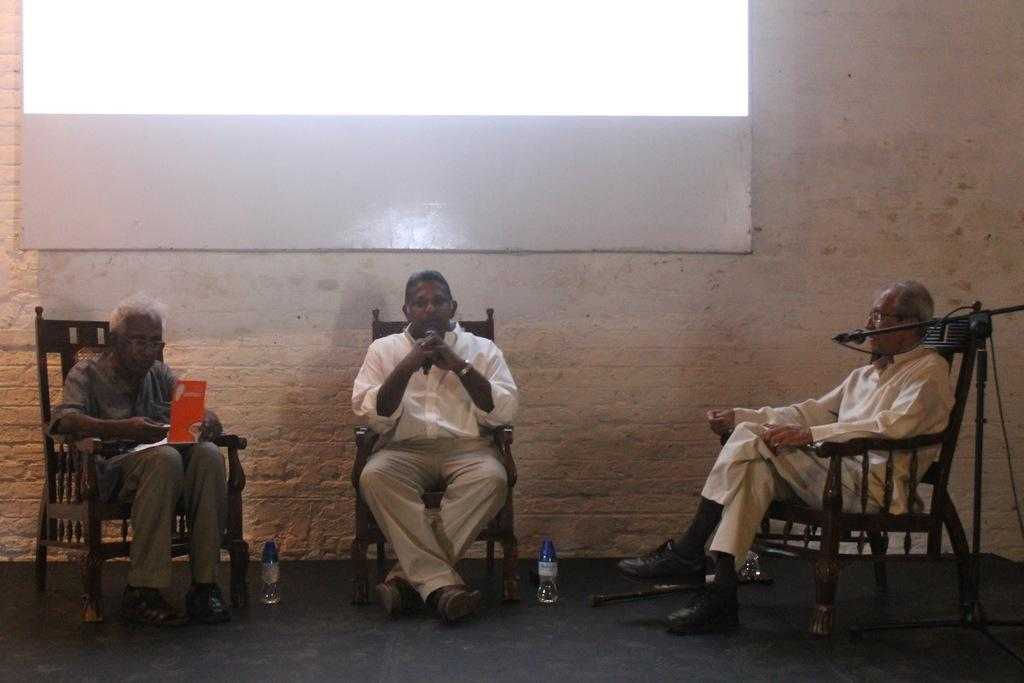How many people are sitting in the image? There are three people sitting on chairs in the image. What objects can be seen besides the people? There are bottles, a stick, a book, and microphones in the image. What can be seen in the background of the image? There is a wall and a screen in the background of the image. What type of flowers can be seen growing on the wall in the image? There are no flowers visible on the wall in the image. What is the chance of winning a prize in the image? There is no indication of a prize or a game in the image, so it's not possible to determine the chance of winning. 